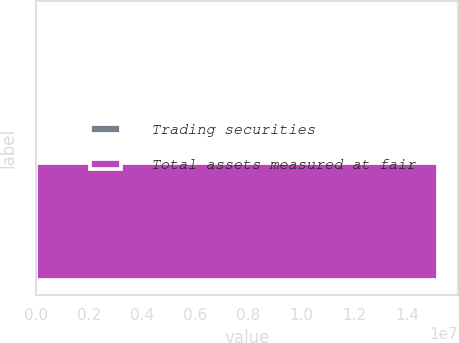<chart> <loc_0><loc_0><loc_500><loc_500><bar_chart><fcel>Trading securities<fcel>Total assets measured at fair<nl><fcel>62173<fcel>1.51548e+07<nl></chart> 